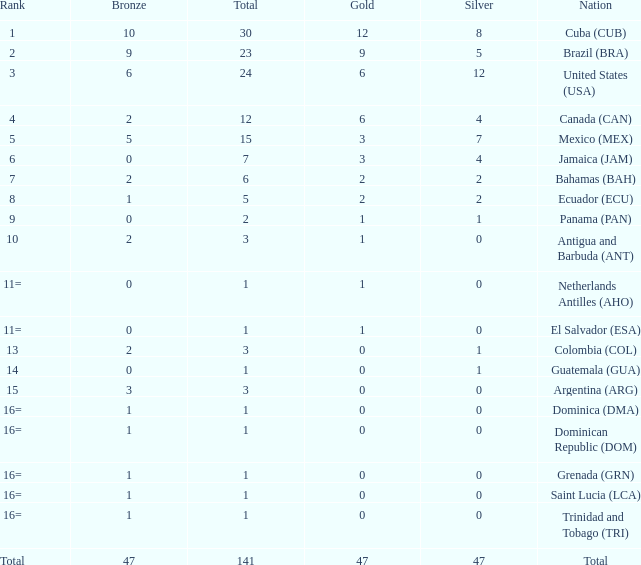How many bronzes have a Nation of jamaica (jam), and a Total smaller than 7? 0.0. 